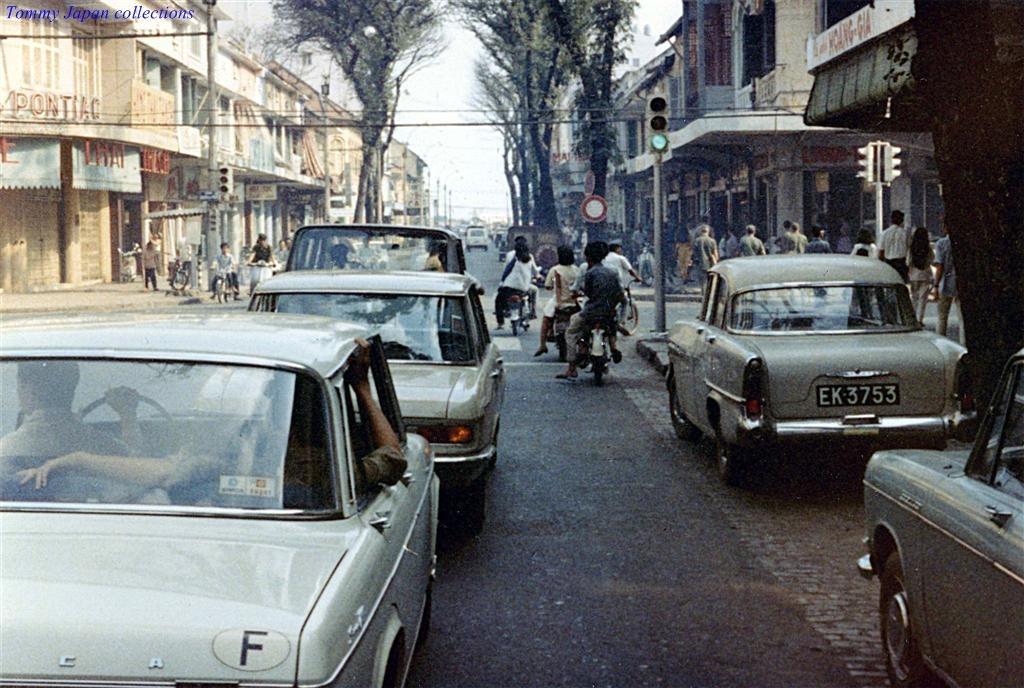Describe this image in one or two sentences. In the image we can see there are cars parked on the road and there are people sitting on the bikes. There are other people standing on the footpath and there are trees and there are buildings. 